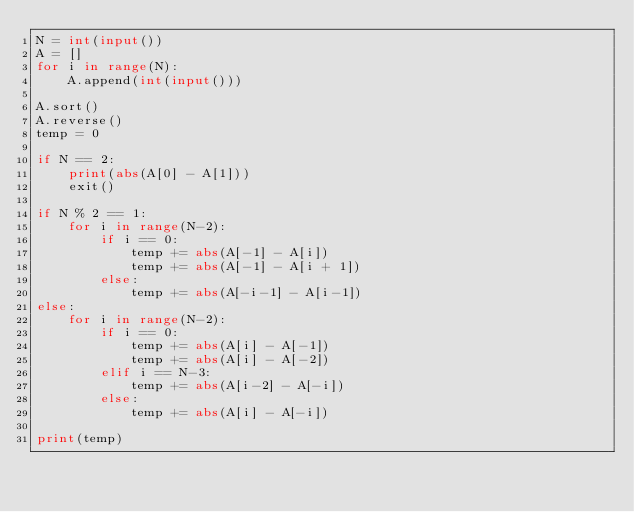Convert code to text. <code><loc_0><loc_0><loc_500><loc_500><_Python_>N = int(input())
A = []
for i in range(N):
    A.append(int(input()))

A.sort()
A.reverse()
temp = 0

if N == 2:
    print(abs(A[0] - A[1]))
    exit()

if N % 2 == 1:
    for i in range(N-2):
        if i == 0:
            temp += abs(A[-1] - A[i])
            temp += abs(A[-1] - A[i + 1])
        else:
            temp += abs(A[-i-1] - A[i-1])
else:
    for i in range(N-2):
        if i == 0:
            temp += abs(A[i] - A[-1])
            temp += abs(A[i] - A[-2])
        elif i == N-3:
            temp += abs(A[i-2] - A[-i])
        else:
            temp += abs(A[i] - A[-i])
        
print(temp)</code> 